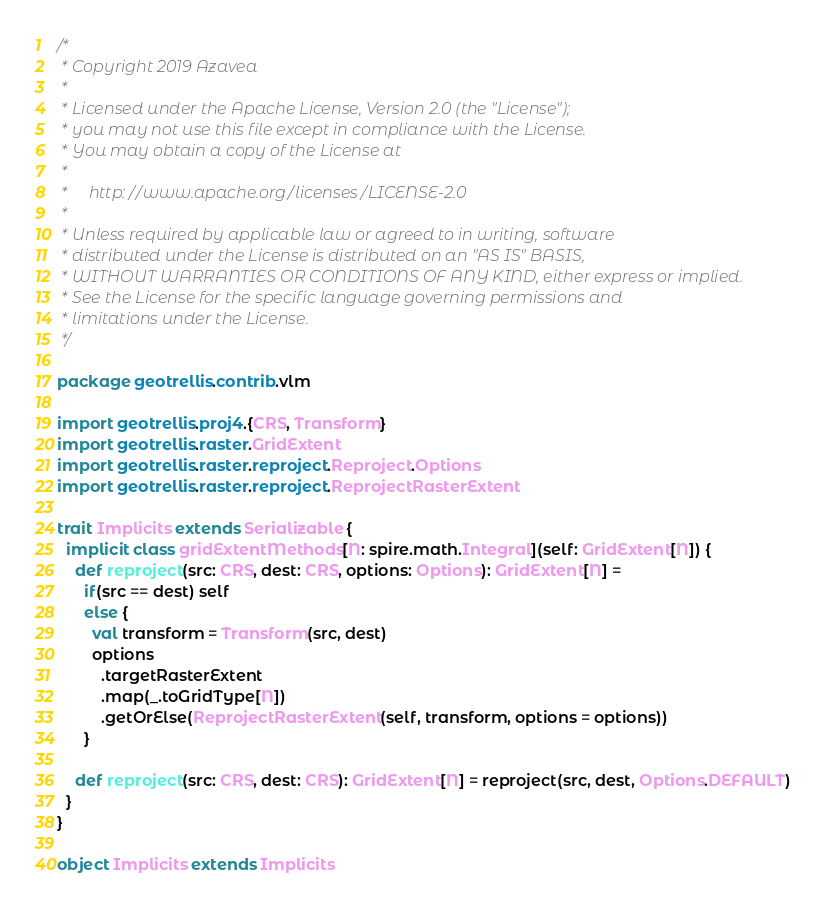<code> <loc_0><loc_0><loc_500><loc_500><_Scala_>/*
 * Copyright 2019 Azavea
 *
 * Licensed under the Apache License, Version 2.0 (the "License");
 * you may not use this file except in compliance with the License.
 * You may obtain a copy of the License at
 *
 *     http://www.apache.org/licenses/LICENSE-2.0
 *
 * Unless required by applicable law or agreed to in writing, software
 * distributed under the License is distributed on an "AS IS" BASIS,
 * WITHOUT WARRANTIES OR CONDITIONS OF ANY KIND, either express or implied.
 * See the License for the specific language governing permissions and
 * limitations under the License.
 */

package geotrellis.contrib.vlm

import geotrellis.proj4.{CRS, Transform}
import geotrellis.raster.GridExtent
import geotrellis.raster.reproject.Reproject.Options
import geotrellis.raster.reproject.ReprojectRasterExtent

trait Implicits extends Serializable {
  implicit class gridExtentMethods[N: spire.math.Integral](self: GridExtent[N]) {
    def reproject(src: CRS, dest: CRS, options: Options): GridExtent[N] =
      if(src == dest) self
      else {
        val transform = Transform(src, dest)
        options
          .targetRasterExtent
          .map(_.toGridType[N])
          .getOrElse(ReprojectRasterExtent(self, transform, options = options))
      }

    def reproject(src: CRS, dest: CRS): GridExtent[N] = reproject(src, dest, Options.DEFAULT)
  }
}

object Implicits extends Implicits
</code> 